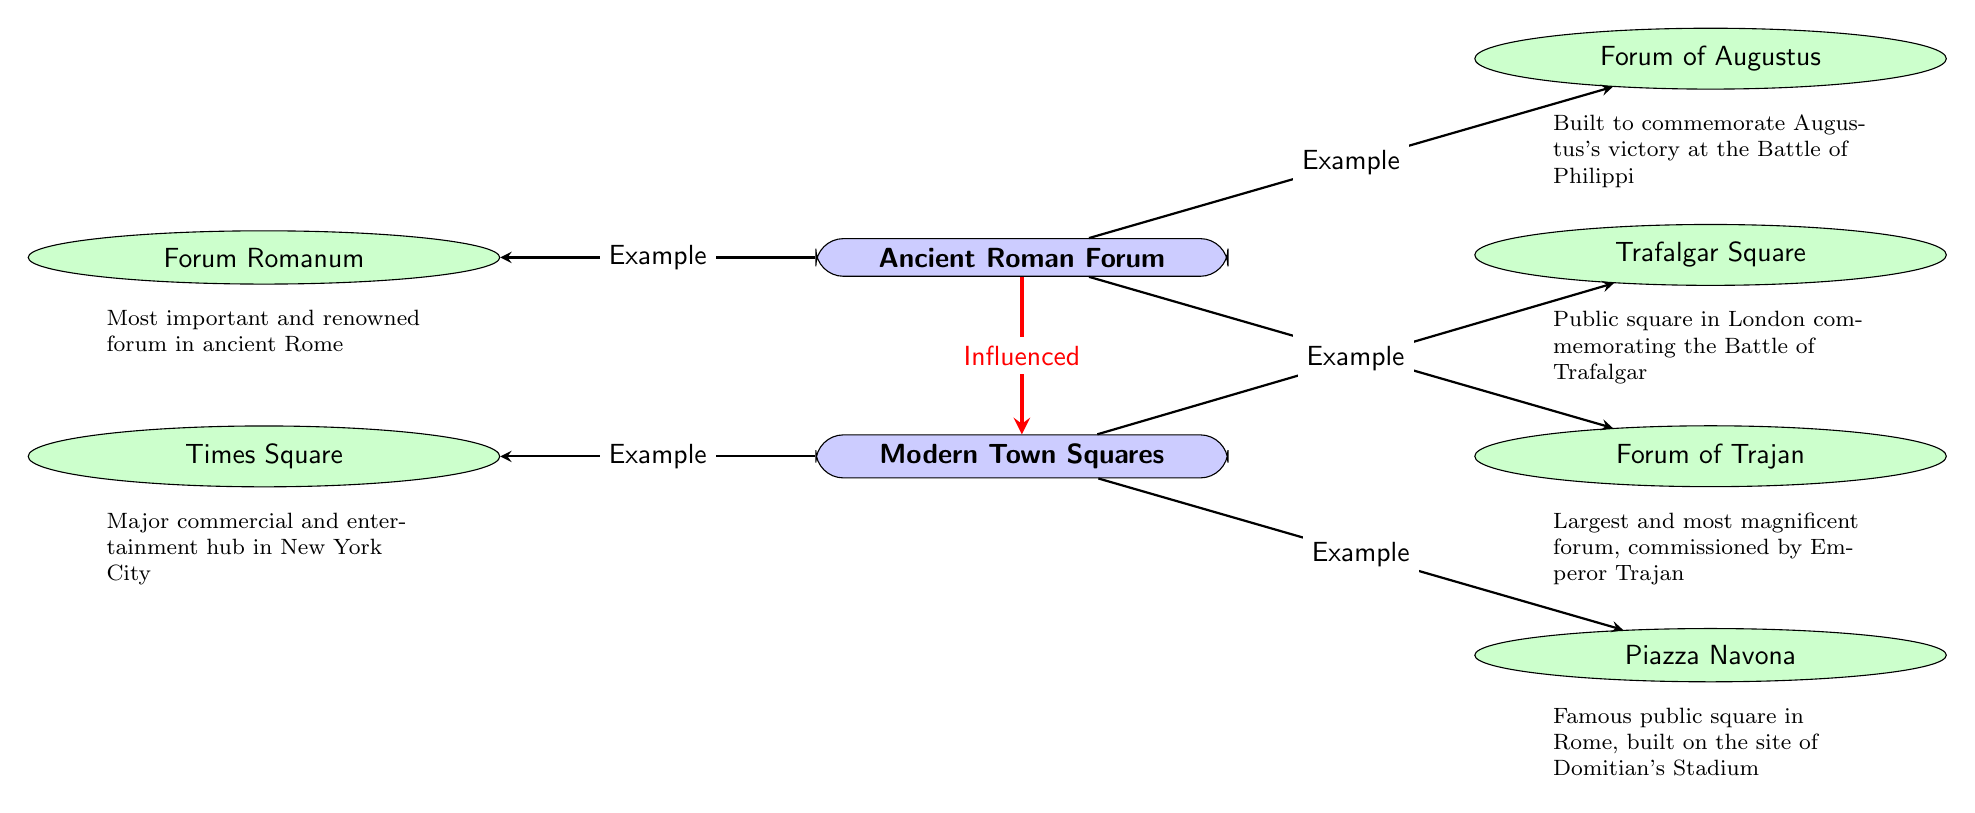What are the examples of Roman Forums listed? The diagram shows three examples of Roman Forums: Forum Romanum, Forum of Augustus, and Forum of Trajan. These are directly connected to the "Ancient Roman Forum" node.
Answer: Forum Romanum, Forum of Augustus, Forum of Trajan How many examples of Modern Town Squares are there? The diagram indicates that there are three examples of Modern Town Squares connected to the "Modern Town Squares" node: Times Square, Piazza Navona, and Trafalgar Square.
Answer: 3 Which forum is described as the largest and most magnificent? According to the description connected to the "Forum of Trajan" node, it states that it is the largest and most magnificent forum, commissioned by Emperor Trajan.
Answer: Forum of Trajan What is the relationship between the Ancient Roman Forum and Modern Town Squares? The diagram uses a red, ultra-thick arrow to highlight the relationship, indicating that Modern Town Squares are influenced by the Ancient Roman Forum.
Answer: Influenced What type of node is "Forum Romanum"? The diagram classifies "Forum Romanum" as a sub-node, which is represented as an ellipse and is color-coded green, illustrating that it is an example of an ancient Roman forum.
Answer: Sub-node (ellipse) What is indicated by the edge from "Modern Town Squares" to "Times Square"? This edge indicates a direct connection where "Times Square" is an example of a Modern Town Square, showing the relationship between the main concept and its examples.
Answer: Example 